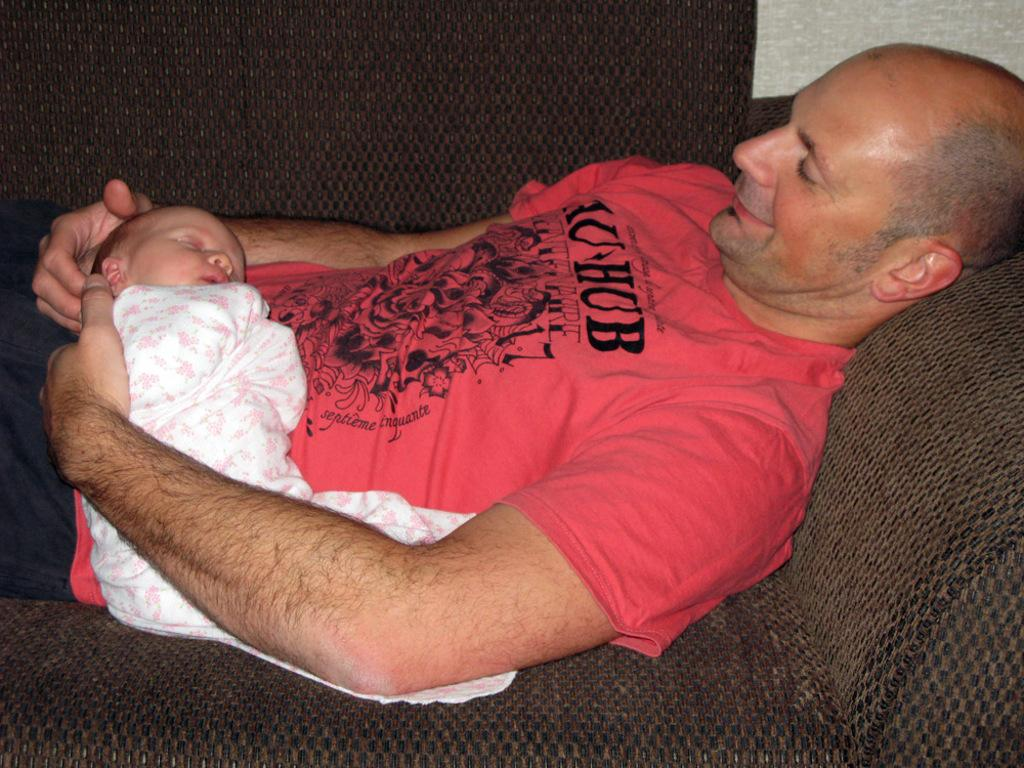Who is the main subject in the image? There is a man in the image. What is the man wearing? The man is wearing a red t-shirt. What is the man doing in the image? The man is holding a baby. What is the man's position in the image? The man is laying on a couch. What is the man's facial expression in the image? The man is smiling. What is the color of the couch in the image? The couch is brown in color. What type of bubble is the man blowing in the image? There is no bubble present in the image. What is the man doing with the celery in the image? There is no celery present in the image. Is the cow visible in the image? There is no cow present in the image. 